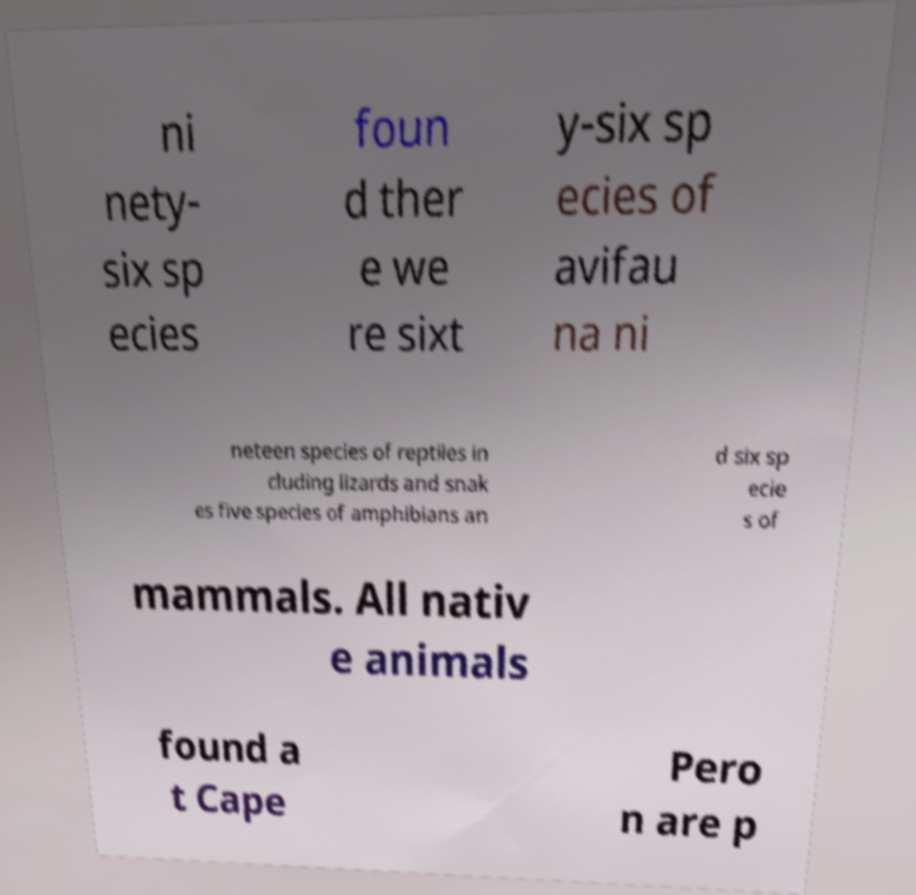Can you accurately transcribe the text from the provided image for me? ni nety- six sp ecies foun d ther e we re sixt y-six sp ecies of avifau na ni neteen species of reptiles in cluding lizards and snak es five species of amphibians an d six sp ecie s of mammals. All nativ e animals found a t Cape Pero n are p 